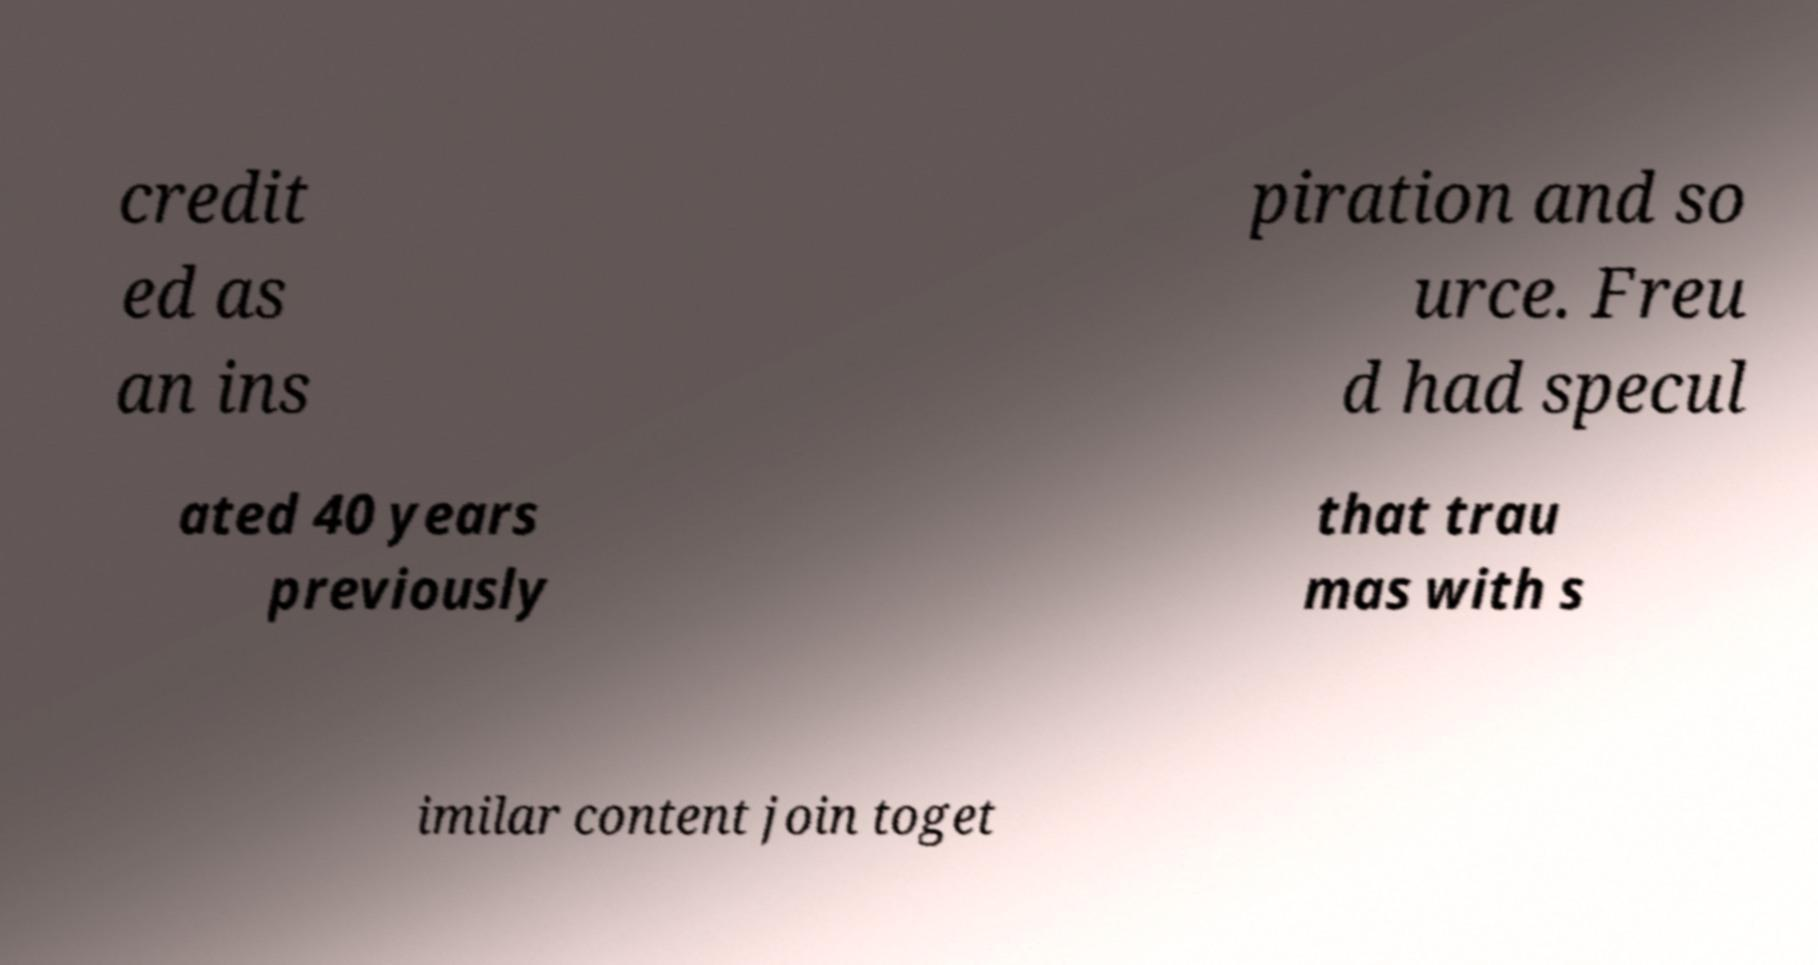What messages or text are displayed in this image? I need them in a readable, typed format. credit ed as an ins piration and so urce. Freu d had specul ated 40 years previously that trau mas with s imilar content join toget 